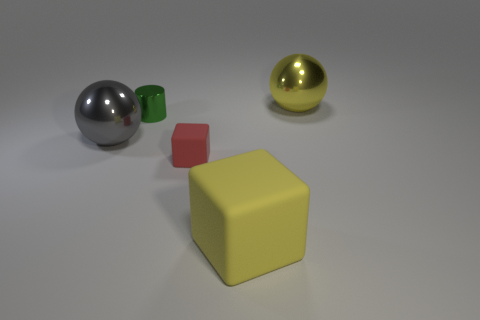Add 1 small rubber objects. How many objects exist? 6 Subtract all spheres. How many objects are left? 3 Subtract 0 yellow cylinders. How many objects are left? 5 Subtract all large yellow cubes. Subtract all small red matte cubes. How many objects are left? 3 Add 5 balls. How many balls are left? 7 Add 4 small cyan matte cubes. How many small cyan matte cubes exist? 4 